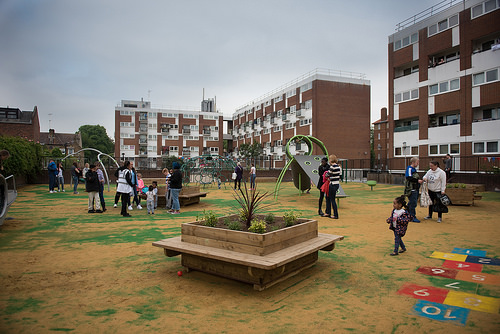<image>
Can you confirm if the man is behind the girl? Yes. From this viewpoint, the man is positioned behind the girl, with the girl partially or fully occluding the man. 